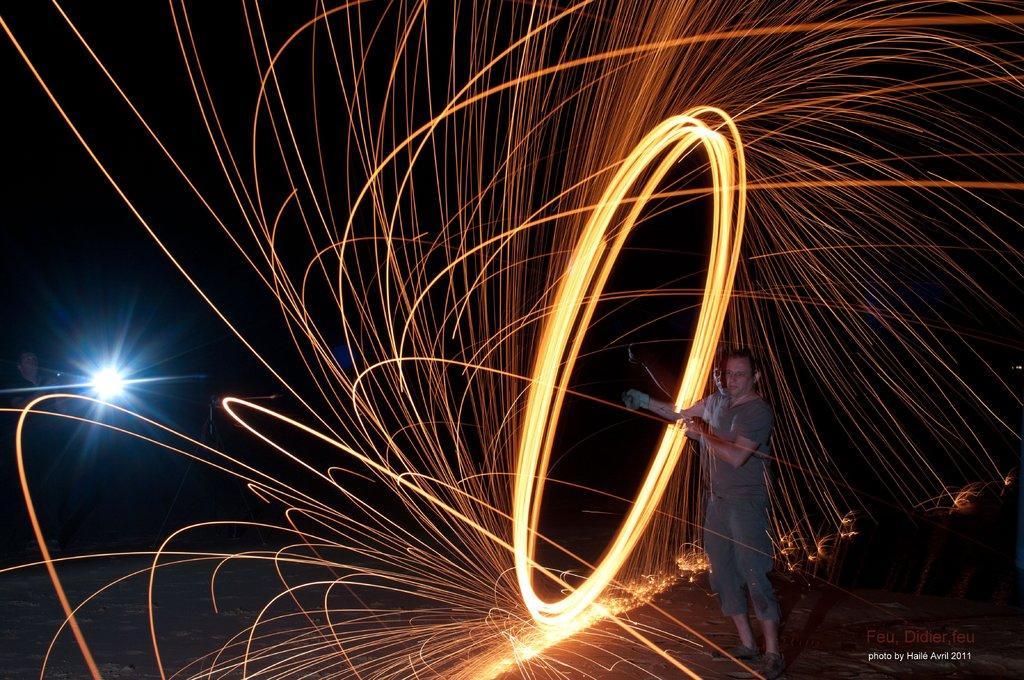In one or two sentences, can you explain what this image depicts? In the foreground of this image, there is a man standing and spinning an object which emits fire sparks. In the background, there is a light in the dark and it seems like a person on the left. 